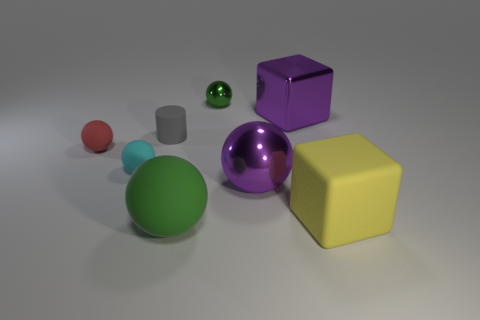There is a green thing that is in front of the big shiny thing that is behind the gray matte cylinder; what is its size?
Your answer should be very brief. Large. How many small objects are purple metallic spheres or red rubber cylinders?
Provide a short and direct response. 0. How big is the green sphere to the right of the big matte object in front of the matte thing on the right side of the tiny green metal object?
Provide a short and direct response. Small. Are there any other things that have the same color as the small cylinder?
Your response must be concise. No. There is a green sphere on the left side of the green ball that is behind the rubber sphere in front of the big yellow matte block; what is it made of?
Provide a succinct answer. Rubber. Is the yellow thing the same shape as the small gray thing?
Provide a short and direct response. No. Is there anything else that has the same material as the tiny cyan thing?
Your response must be concise. Yes. How many large things are in front of the purple metallic cube and on the left side of the matte cube?
Keep it short and to the point. 2. The large thing that is on the left side of the purple thing that is on the left side of the purple block is what color?
Provide a succinct answer. Green. Are there an equal number of large purple shiny blocks that are behind the purple block and tiny cyan things?
Keep it short and to the point. No. 